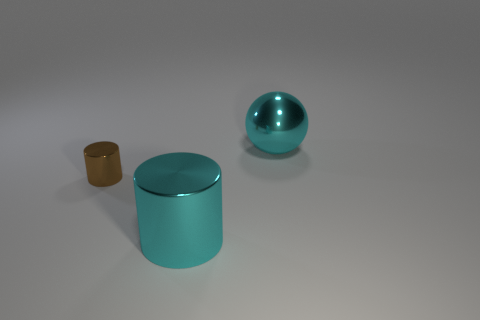How many cylinders are brown shiny things or big cyan objects?
Provide a short and direct response. 2. Is the color of the metal thing that is behind the tiny brown metal cylinder the same as the big cylinder?
Offer a very short reply. Yes. Do the brown shiny object and the cyan metal cylinder have the same size?
Offer a terse response. No. Does the large cylinder have the same color as the object that is to the right of the big cyan shiny cylinder?
Offer a very short reply. Yes. There is a large thing that is made of the same material as the big cylinder; what is its shape?
Offer a very short reply. Sphere. There is a cyan object in front of the cyan sphere; is its shape the same as the tiny brown shiny object?
Give a very brief answer. Yes. What is the size of the object that is to the right of the big cyan object in front of the small brown object?
Offer a terse response. Large. What is the color of the big object that is made of the same material as the cyan cylinder?
Offer a very short reply. Cyan. What number of cylinders have the same size as the cyan shiny ball?
Your answer should be compact. 1. How many cyan things are metallic spheres or tiny metallic cubes?
Provide a succinct answer. 1. 